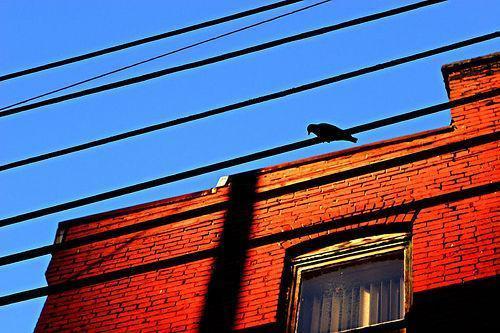How many wires do not have a bird?
Give a very brief answer. 6. 